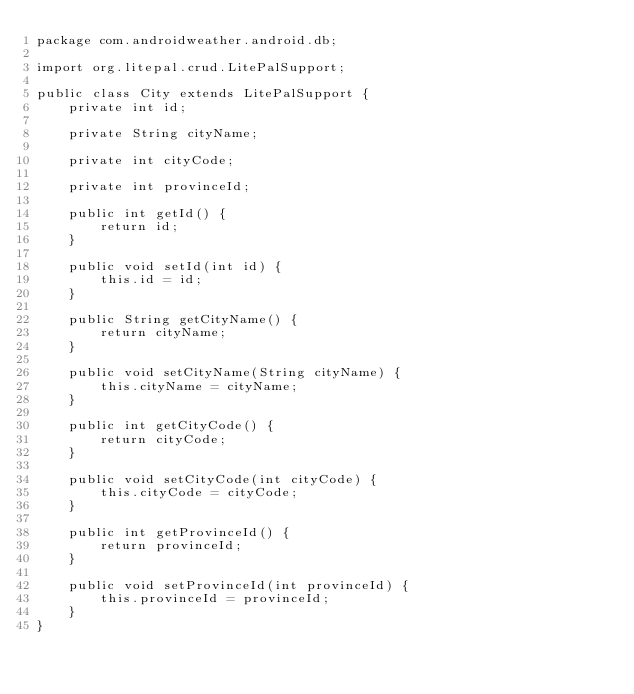<code> <loc_0><loc_0><loc_500><loc_500><_Java_>package com.androidweather.android.db;

import org.litepal.crud.LitePalSupport;

public class City extends LitePalSupport {
    private int id;

    private String cityName;

    private int cityCode;

    private int provinceId;

    public int getId() {
        return id;
    }

    public void setId(int id) {
        this.id = id;
    }

    public String getCityName() {
        return cityName;
    }

    public void setCityName(String cityName) {
        this.cityName = cityName;
    }

    public int getCityCode() {
        return cityCode;
    }

    public void setCityCode(int cityCode) {
        this.cityCode = cityCode;
    }

    public int getProvinceId() {
        return provinceId;
    }

    public void setProvinceId(int provinceId) {
        this.provinceId = provinceId;
    }
}
</code> 